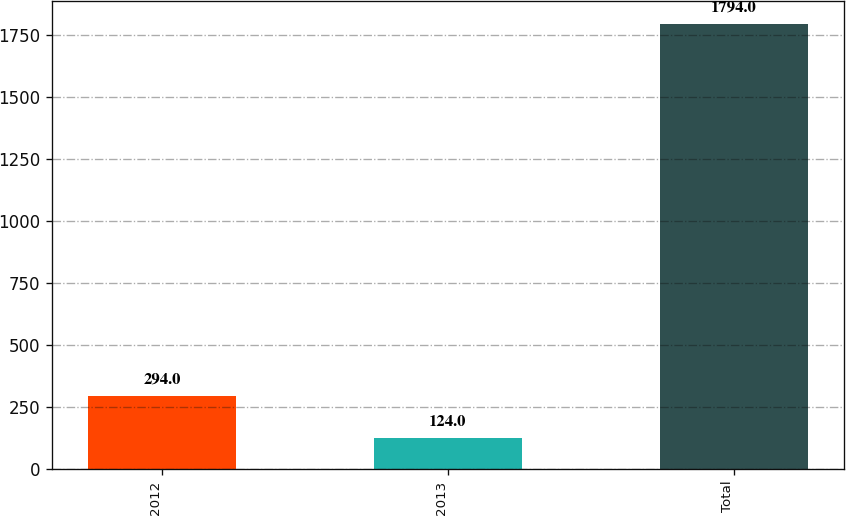Convert chart. <chart><loc_0><loc_0><loc_500><loc_500><bar_chart><fcel>2012<fcel>2013<fcel>Total<nl><fcel>294<fcel>124<fcel>1794<nl></chart> 